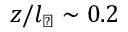Convert formula to latex. <formula><loc_0><loc_0><loc_500><loc_500>z / l _ { \perp } \sim 0 . 2</formula> 